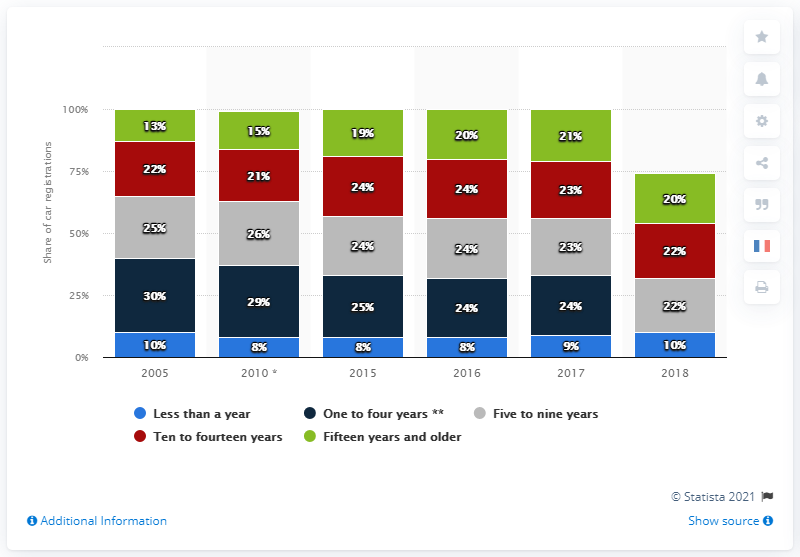Mention a couple of crucial points in this snapshot. In 2005, approximately 13% of new vehicles that were 15 years old or older were registered. 